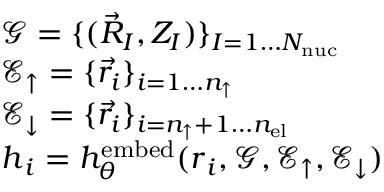<formula> <loc_0><loc_0><loc_500><loc_500>\begin{array} { r l } & { \mathcal { G } = \{ ( \vec { R } _ { I } , Z _ { I } ) \} _ { I = 1 \dots { N _ { n u c } } } } \\ & { \mathcal { E } _ { \uparrow } = \{ \vec { r } _ { i } \} _ { i = 1 \dots { n _ { \uparrow } } } } \\ & { \mathcal { E } _ { \downarrow } = \{ \vec { r } _ { i } \} _ { i = { n _ { \uparrow } } + 1 \dots { n _ { e l } } } } \\ & { { h } _ { i } = h _ { \theta } ^ { e m b e d } ( { r } _ { i } , \mathcal { G } , \mathcal { E } _ { \uparrow } , \mathcal { E } _ { \downarrow } ) } \end{array}</formula> 